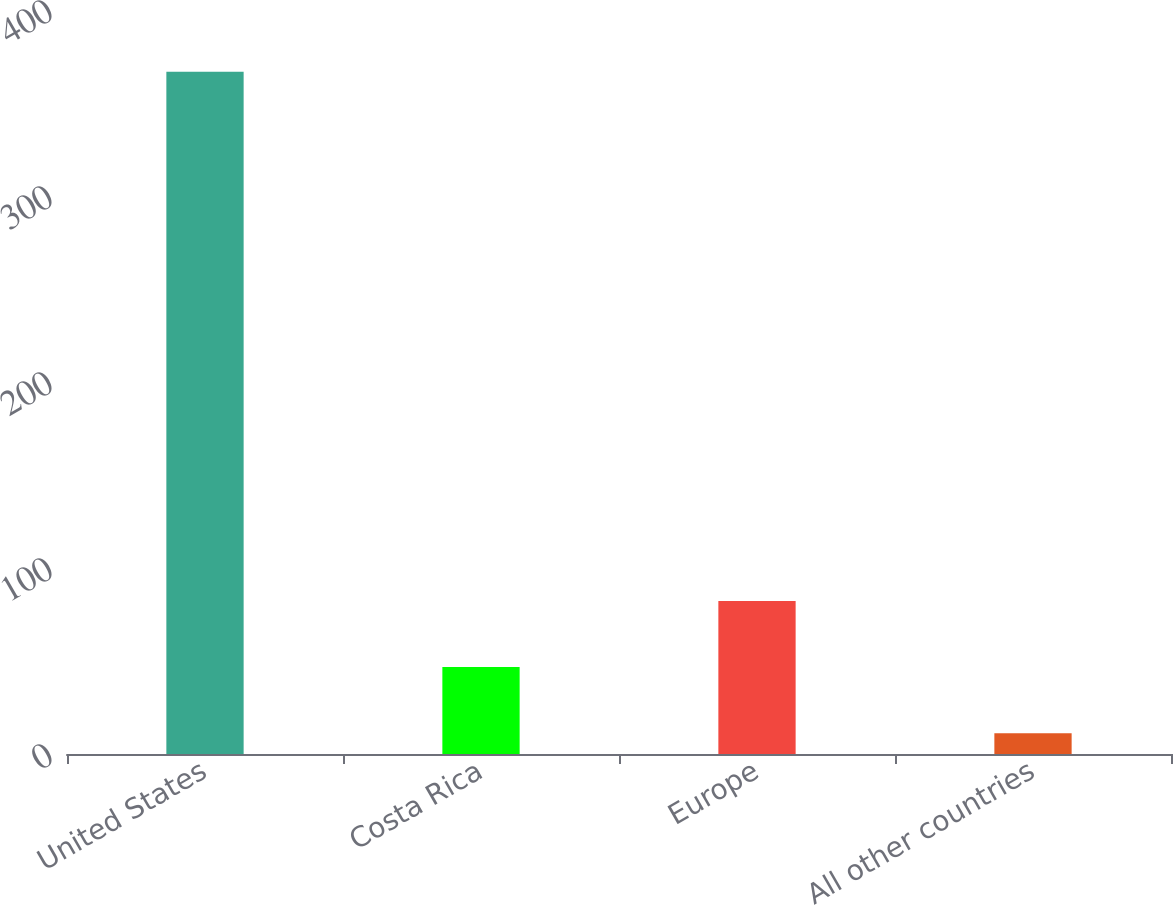Convert chart. <chart><loc_0><loc_0><loc_500><loc_500><bar_chart><fcel>United States<fcel>Costa Rica<fcel>Europe<fcel>All other countries<nl><fcel>366.8<fcel>46.76<fcel>82.32<fcel>11.2<nl></chart> 